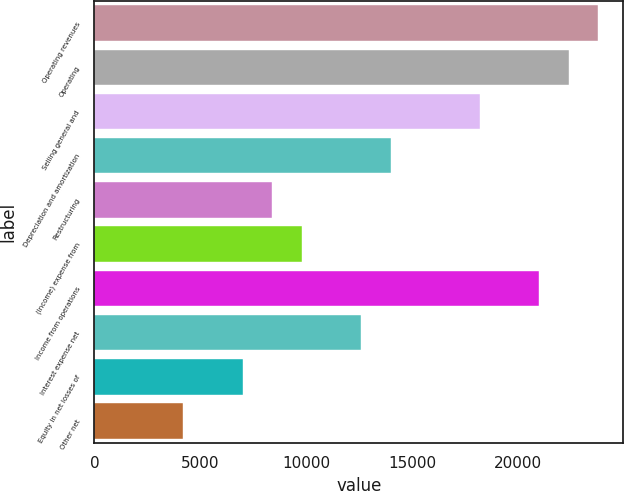Convert chart. <chart><loc_0><loc_0><loc_500><loc_500><bar_chart><fcel>Operating revenues<fcel>Operating<fcel>Selling general and<fcel>Depreciation and amortization<fcel>Restructuring<fcel>(Income) expense from<fcel>Income from operations<fcel>Interest expense net<fcel>Equity in net losses of<fcel>Other net<nl><fcel>23792.2<fcel>22392.7<fcel>18194.3<fcel>13996<fcel>8398.2<fcel>9797.65<fcel>20993.2<fcel>12596.5<fcel>6998.75<fcel>4199.85<nl></chart> 